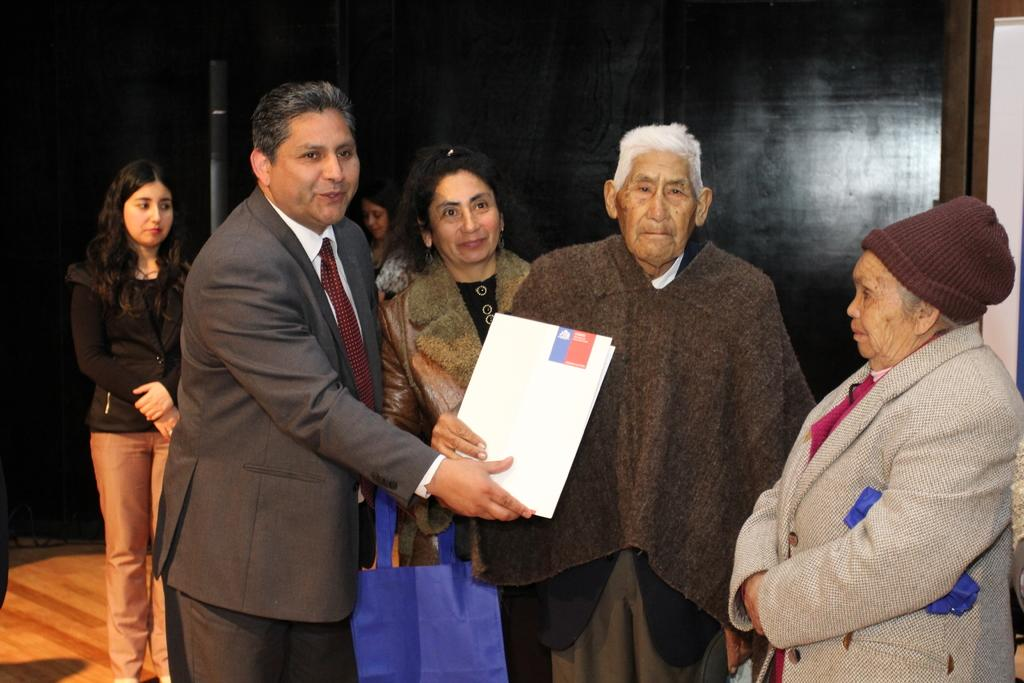Who is the main subject in the image? There is a guy in the image. What is the guy doing in the image? The guy is presenting a sheet to an old man. Can you describe the other person in the image? There is an old man in the image. What else can be seen in the background of the image? There are women standing in the background of the image. What type of cabbage is being used as a prop in the image? There is no cabbage present in the image. Can you describe the shape of the snake in the image? There is no snake present in the image. 